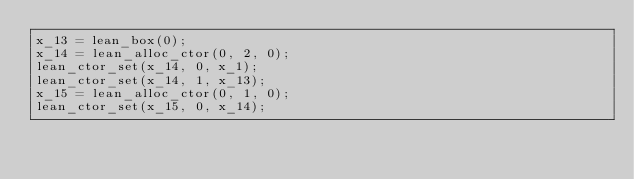<code> <loc_0><loc_0><loc_500><loc_500><_C_>x_13 = lean_box(0);
x_14 = lean_alloc_ctor(0, 2, 0);
lean_ctor_set(x_14, 0, x_1);
lean_ctor_set(x_14, 1, x_13);
x_15 = lean_alloc_ctor(0, 1, 0);
lean_ctor_set(x_15, 0, x_14);</code> 